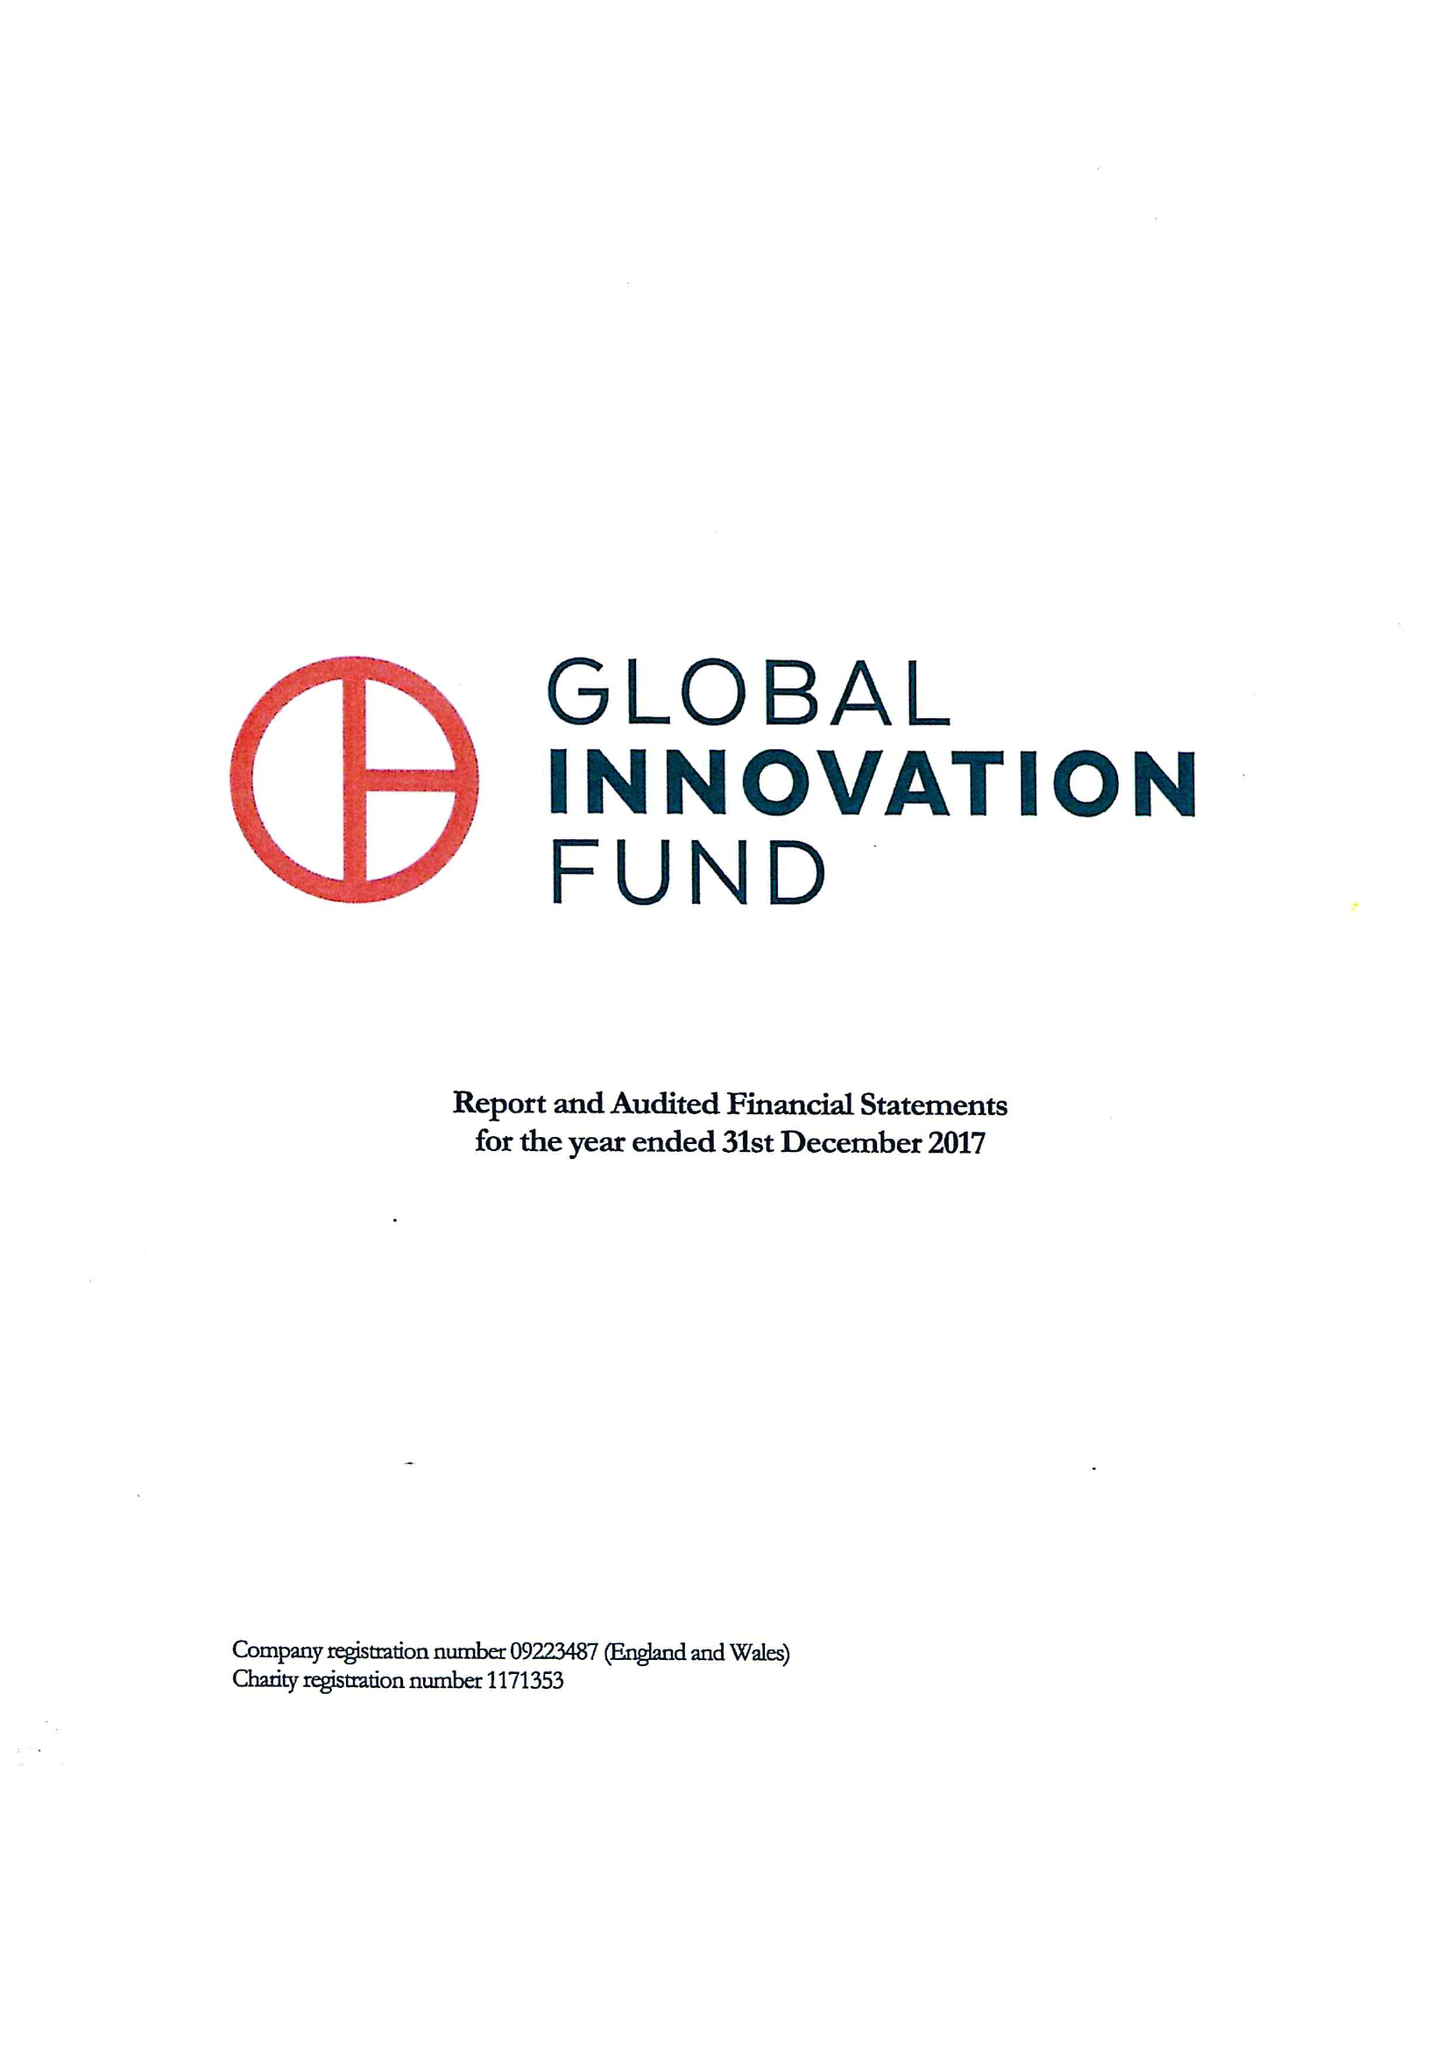What is the value for the address__post_town?
Answer the question using a single word or phrase. LONDON 